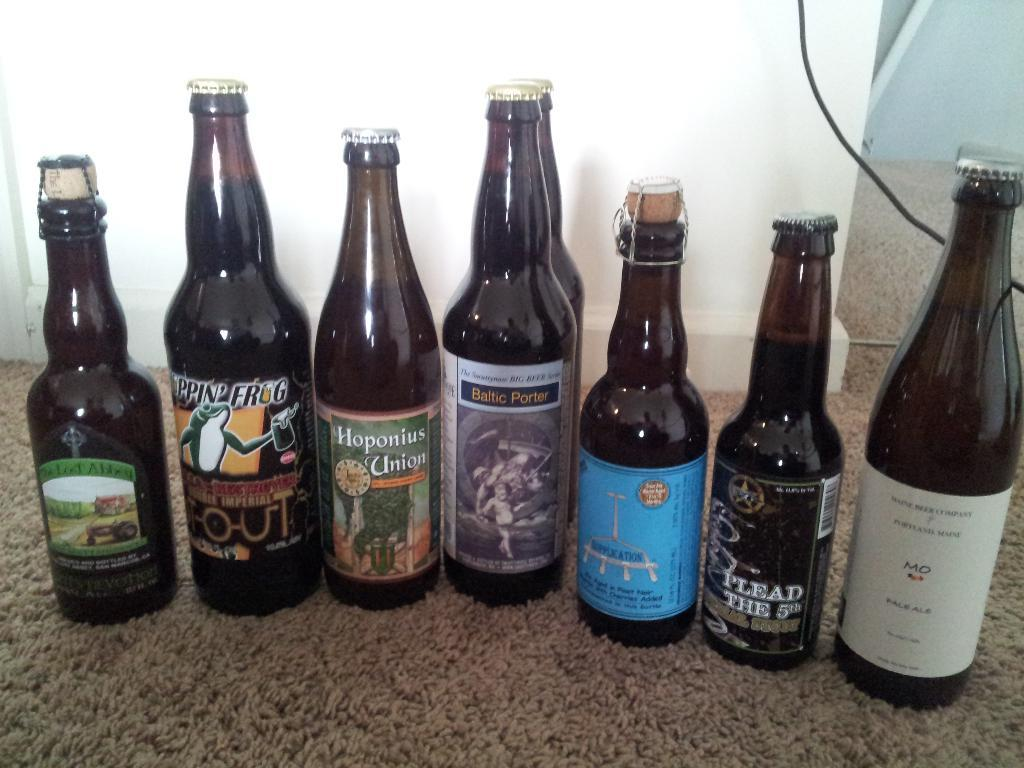<image>
Provide a brief description of the given image. Several bottles of beer one called Plead the 5th sit on a table 